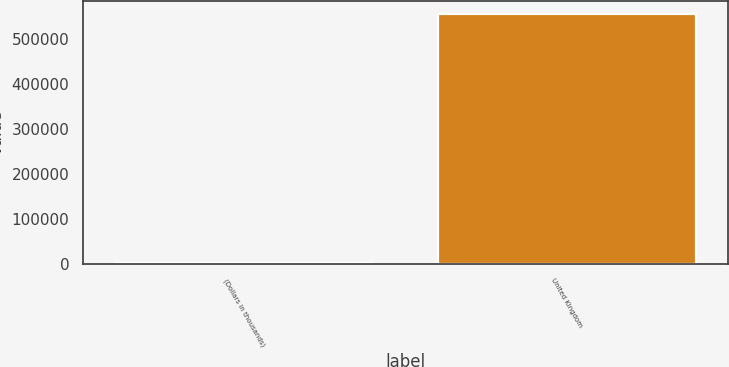Convert chart. <chart><loc_0><loc_0><loc_500><loc_500><bar_chart><fcel>(Dollars in thousands)<fcel>United Kingdom<nl><fcel>2013<fcel>555332<nl></chart> 